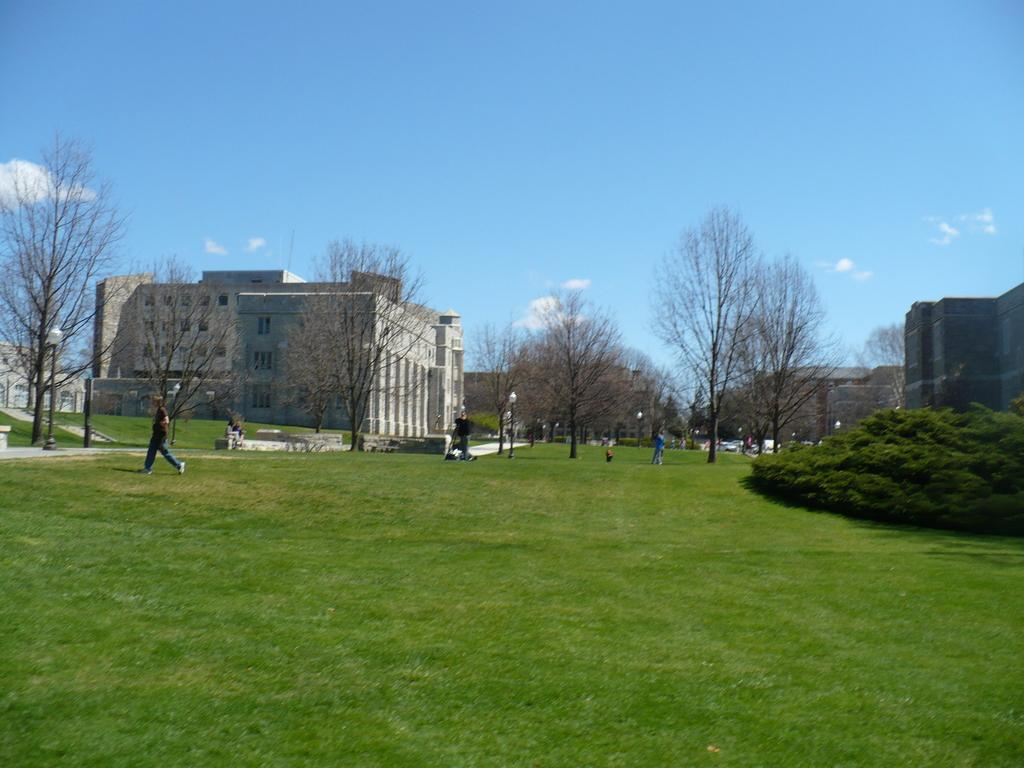What type of structures can be seen in the image? There are buildings in the image. What are the people in the image doing? There are persons standing on the ground in the image. What objects can be seen along the streets in the image? Street poles and street lights are visible in the image. What type of vegetation is present in the image? Trees are present in the image. What is visible in the sky in the image? The sky is visible in the image, and clouds are visible in the sky. Can you see any feathers floating in the sky in the image? There are no feathers visible in the sky in the image. What type of bone is present in the image? There are no bones present in the image. 